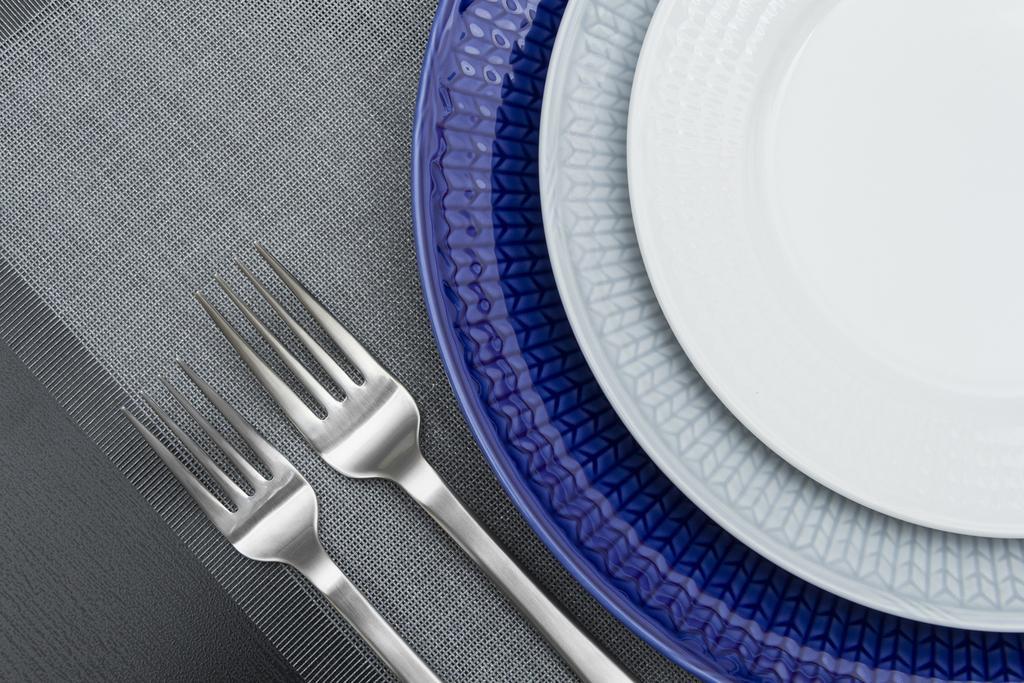Could you give a brief overview of what you see in this image? In this image I see the plates which are of violet and white in color and I see 2 forks over here and all these things are on the white and grey color surface. 